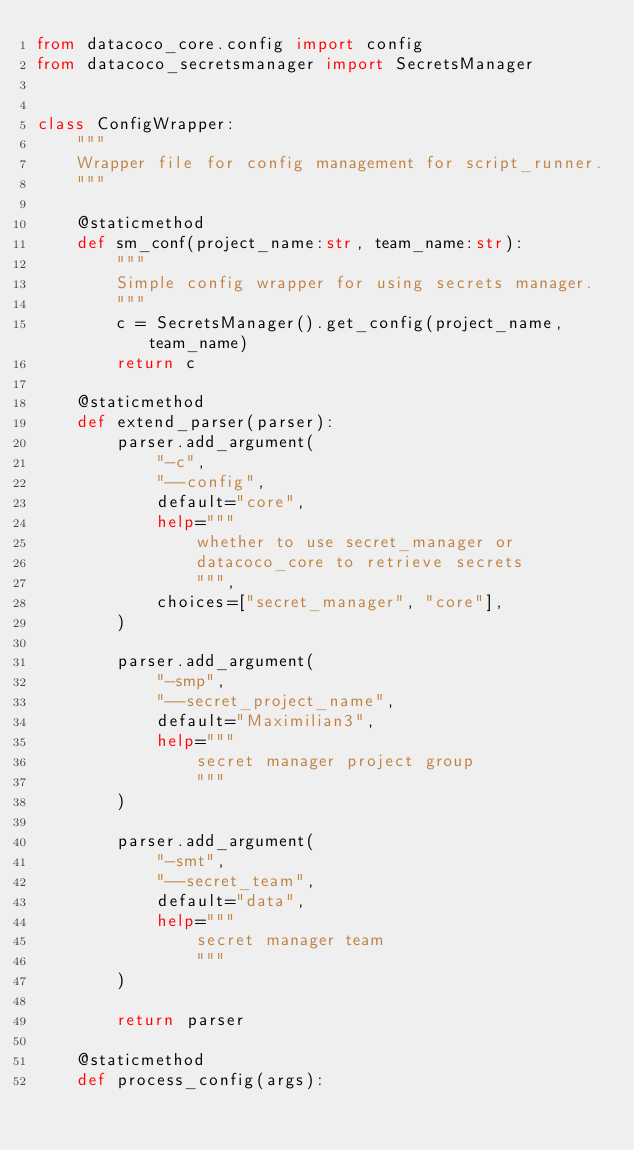Convert code to text. <code><loc_0><loc_0><loc_500><loc_500><_Python_>from datacoco_core.config import config
from datacoco_secretsmanager import SecretsManager


class ConfigWrapper:
    """
    Wrapper file for config management for script_runner.
    """

    @staticmethod
    def sm_conf(project_name:str, team_name:str):
        """
        Simple config wrapper for using secrets manager.
        """
        c = SecretsManager().get_config(project_name, team_name)
        return c

    @staticmethod
    def extend_parser(parser):
        parser.add_argument(
            "-c",
            "--config",
            default="core",
            help="""
                whether to use secret_manager or
                datacoco_core to retrieve secrets
                """,
            choices=["secret_manager", "core"],
        )

        parser.add_argument(
            "-smp",
            "--secret_project_name",
            default="Maximilian3",
            help="""
                secret manager project group
                """
        )

        parser.add_argument(
            "-smt",
            "--secret_team",
            default="data",
            help="""
                secret manager team
                """
        )

        return parser

    @staticmethod
    def process_config(args):</code> 